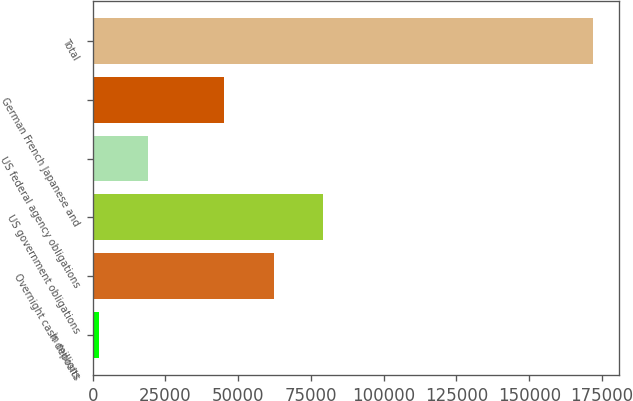Convert chart to OTSL. <chart><loc_0><loc_0><loc_500><loc_500><bar_chart><fcel>in millions<fcel>Overnight cash deposits<fcel>US government obligations<fcel>US federal agency obligations<fcel>German French Japanese and<fcel>Total<nl><fcel>2012<fcel>62178.3<fcel>79186.6<fcel>19020.3<fcel>45170<fcel>172095<nl></chart> 